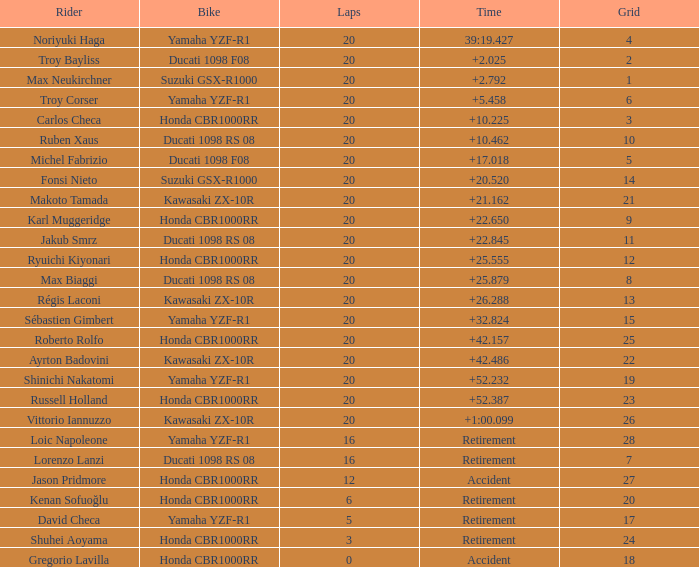What is the time of Troy Bayliss with less than 8 grids? 2.025. 